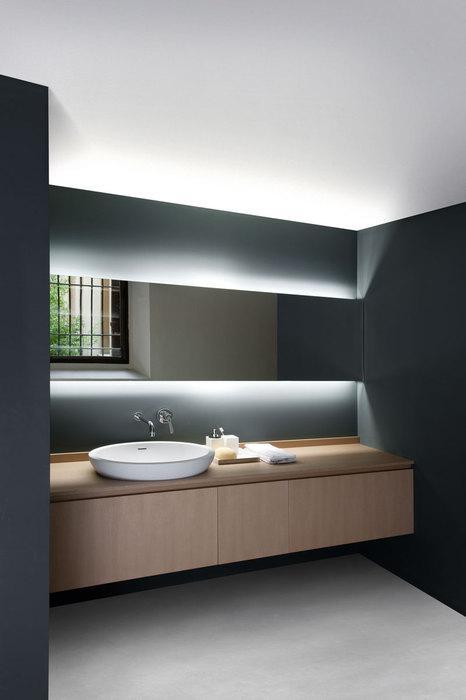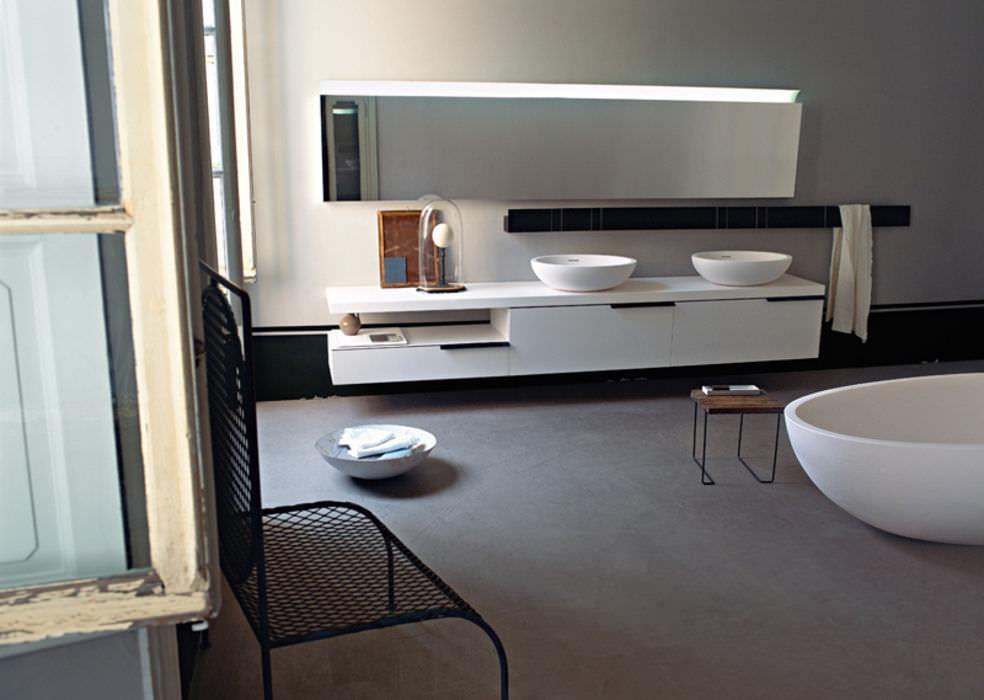The first image is the image on the left, the second image is the image on the right. Analyze the images presented: Is the assertion "There are four white folded towels in a shelf under a sink." valid? Answer yes or no. No. The first image is the image on the left, the second image is the image on the right. For the images shown, is this caption "There are two basins on the counter in the image on the right." true? Answer yes or no. Yes. 